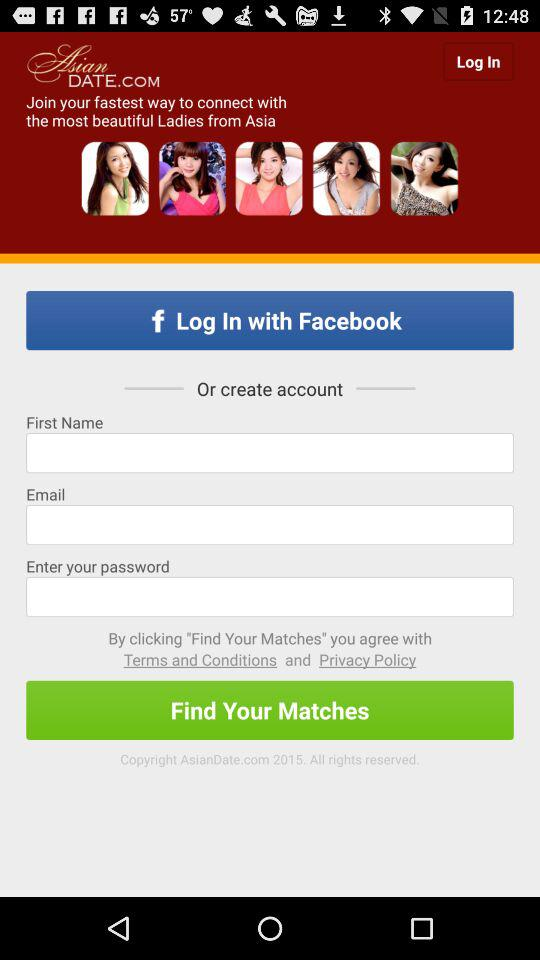What is the name of the application? The name of the application is "AsianDate". 